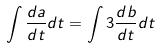<formula> <loc_0><loc_0><loc_500><loc_500>\int \frac { d a } { d t } d t = \int 3 \frac { d b } { d t } d t</formula> 